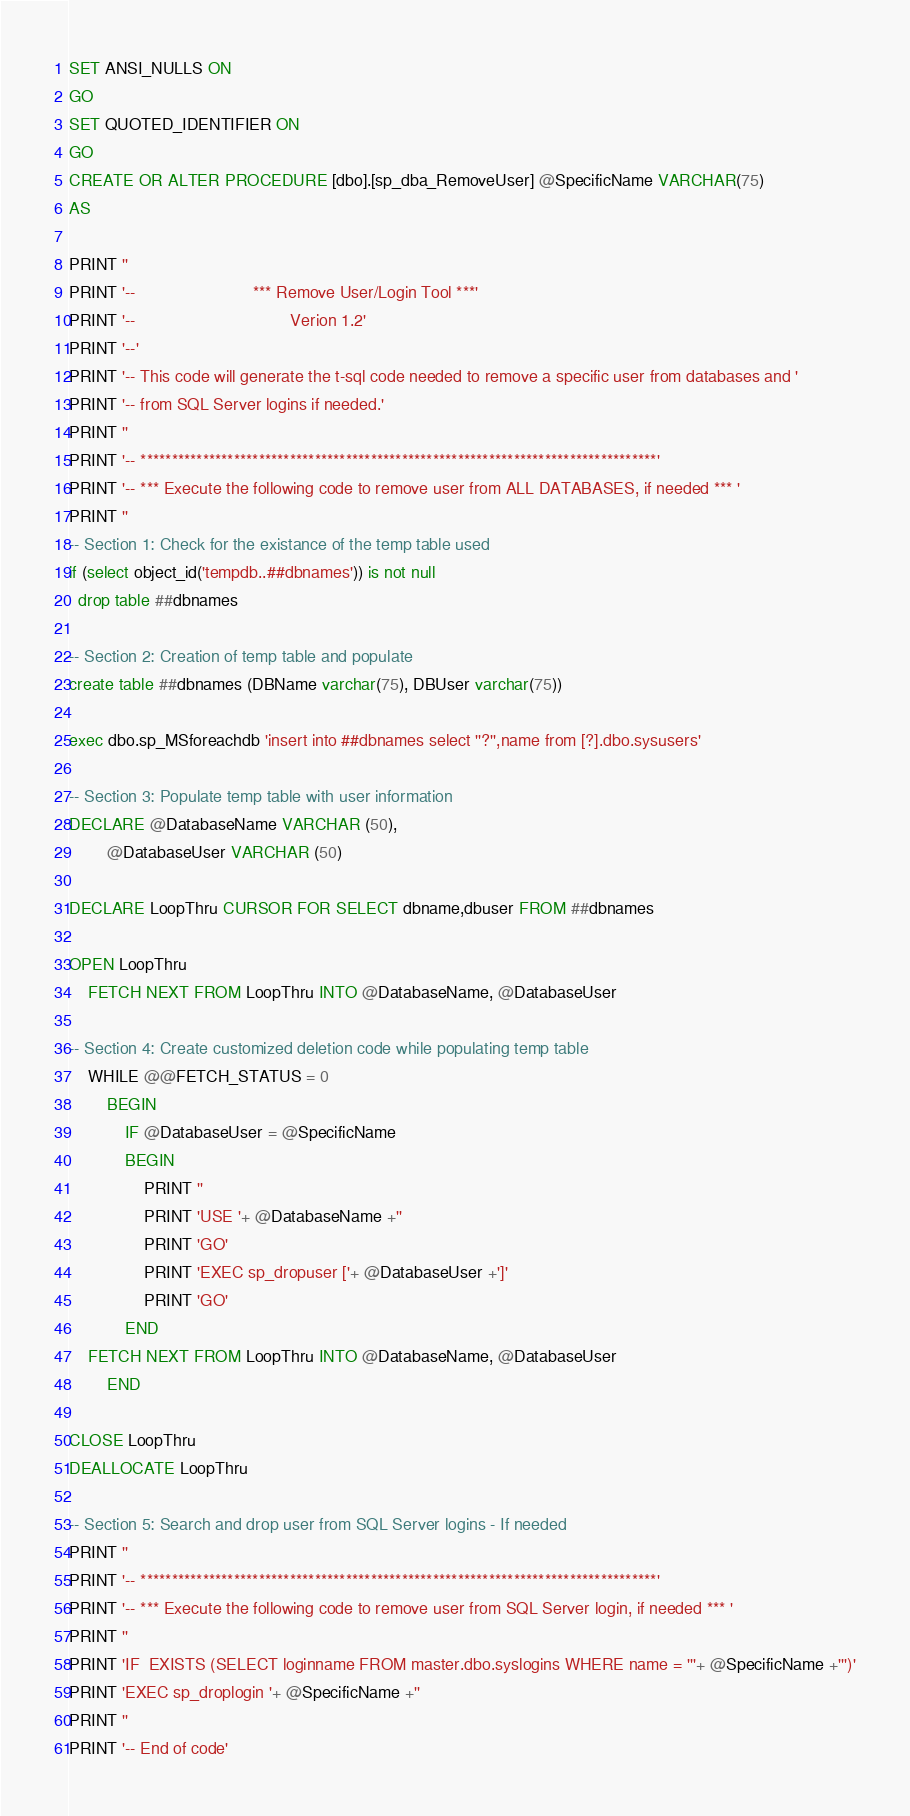<code> <loc_0><loc_0><loc_500><loc_500><_SQL_>SET ANSI_NULLS ON
GO
SET QUOTED_IDENTIFIER ON
GO
CREATE OR ALTER PROCEDURE [dbo].[sp_dba_RemoveUser] @SpecificName VARCHAR(75)
AS

PRINT ''
PRINT '--                         *** Remove User/Login Tool ***'
PRINT '--									Verion 1.2'
PRINT '--'
PRINT '-- This code will generate the t-sql code needed to remove a specific user from databases and '
PRINT '-- from SQL Server logins if needed.' 
PRINT ''
PRINT '-- ***********************************************************************************'
PRINT '-- *** Execute the following code to remove user from ALL DATABASES, if needed *** '
PRINT ''
-- Section 1: Check for the existance of the temp table used
if (select object_id('tempdb..##dbnames')) is not null
  drop table ##dbnames

-- Section 2: Creation of temp table and populate
create table ##dbnames (DBName varchar(75), DBUser varchar(75))

exec dbo.sp_MSforeachdb 'insert into ##dbnames select ''?'',name from [?].dbo.sysusers'

-- Section 3: Populate temp table with user information 
DECLARE @DatabaseName VARCHAR (50),
		@DatabaseUser VARCHAR (50)
        
DECLARE LoopThru CURSOR FOR SELECT dbname,dbuser FROM ##dbnames

OPEN LoopThru
	FETCH NEXT FROM LoopThru INTO @DatabaseName, @DatabaseUser
	
-- Section 4: Create customized deletion code while populating temp table
	WHILE @@FETCH_STATUS = 0
		BEGIN
			IF @DatabaseUser = @SpecificName	
			BEGIN
				PRINT ''
				PRINT 'USE '+ @DatabaseName +''
				PRINT 'GO'
				PRINT 'EXEC sp_dropuser ['+ @DatabaseUser +']' 
				PRINT 'GO'
			END
	FETCH NEXT FROM LoopThru INTO @DatabaseName, @DatabaseUser
		END

CLOSE LoopThru
DEALLOCATE LoopThru

-- Section 5: Search and drop user from SQL Server logins - If needed
PRINT ''
PRINT '-- ***********************************************************************************'
PRINT '-- *** Execute the following code to remove user from SQL Server login, if needed *** '
PRINT ''
PRINT 'IF  EXISTS (SELECT loginname FROM master.dbo.syslogins WHERE name = '''+ @SpecificName +''')'
PRINT 'EXEC sp_droplogin '+ @SpecificName +'' 
PRINT ''
PRINT '-- End of code'</code> 